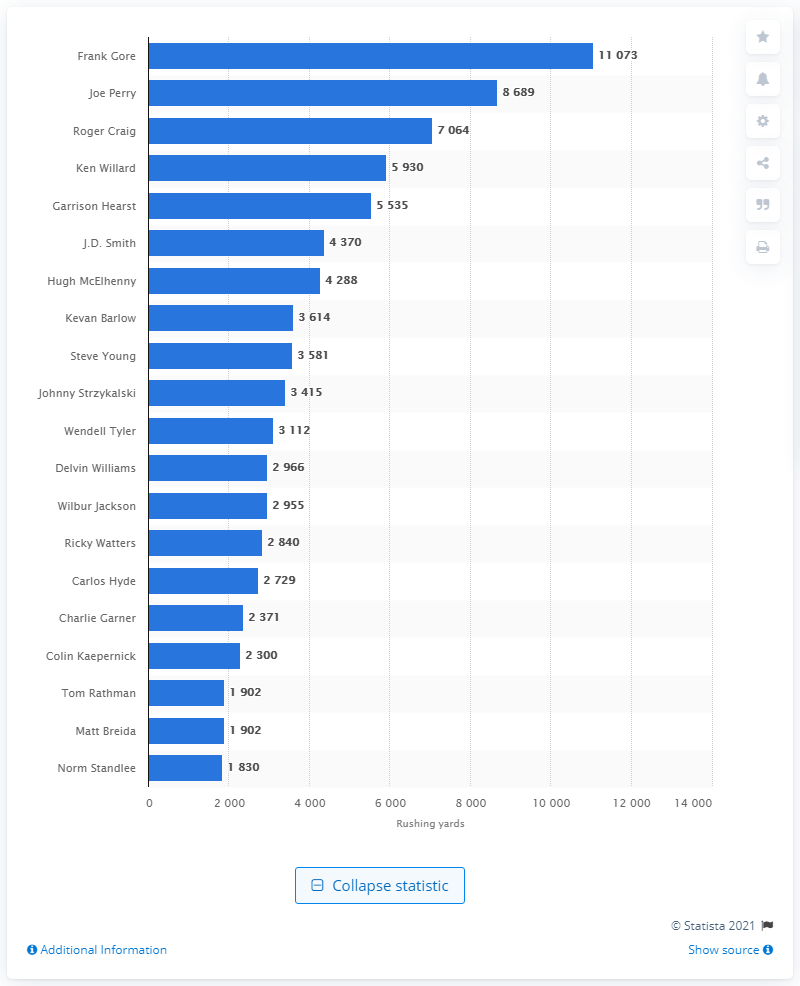Draw attention to some important aspects in this diagram. The career rushing leader of the San Francisco 49ers is Frank Gore. 